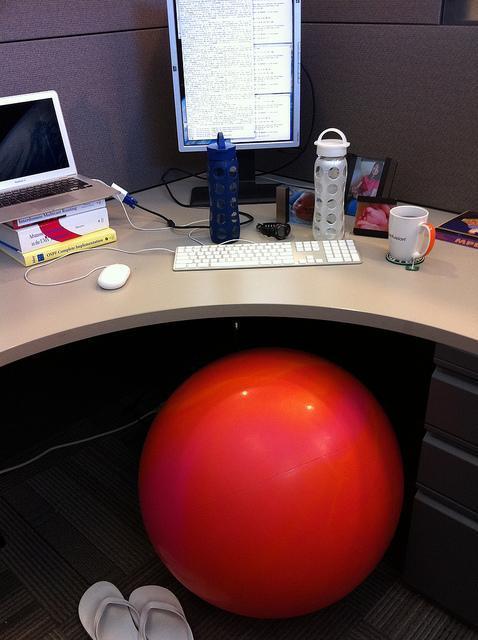Does the image validate the caption "The sports ball is next to the tv."?
Answer yes or no. No. 